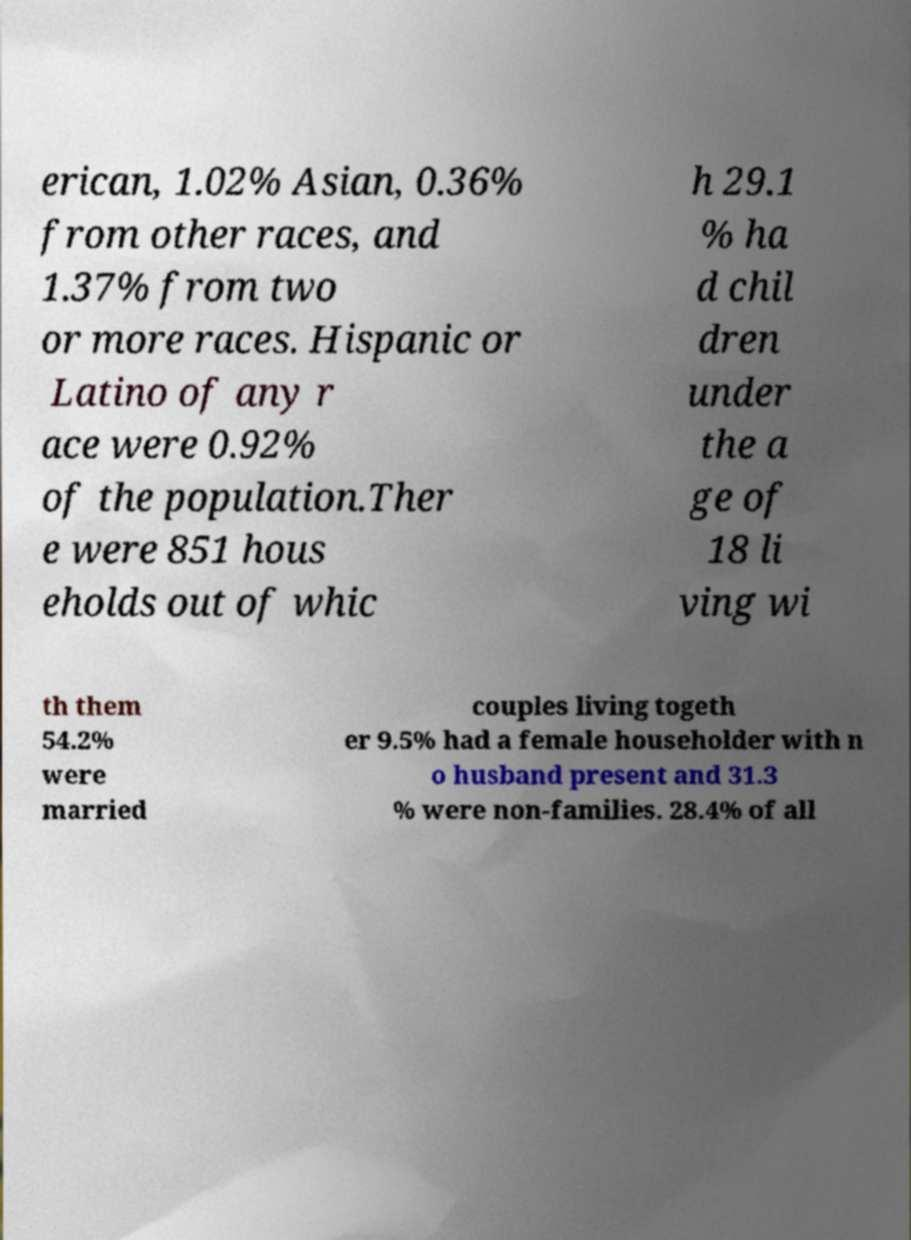What messages or text are displayed in this image? I need them in a readable, typed format. erican, 1.02% Asian, 0.36% from other races, and 1.37% from two or more races. Hispanic or Latino of any r ace were 0.92% of the population.Ther e were 851 hous eholds out of whic h 29.1 % ha d chil dren under the a ge of 18 li ving wi th them 54.2% were married couples living togeth er 9.5% had a female householder with n o husband present and 31.3 % were non-families. 28.4% of all 